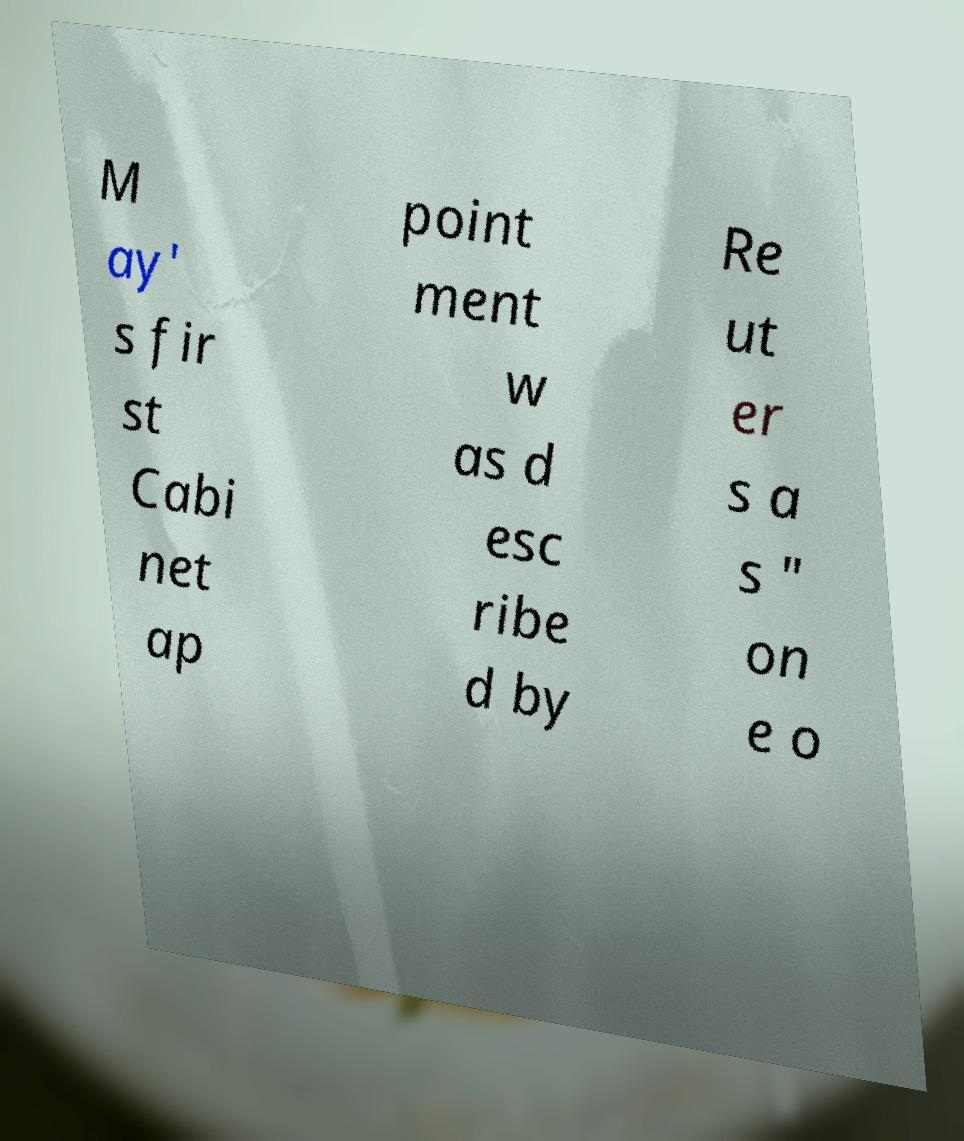Can you read and provide the text displayed in the image?This photo seems to have some interesting text. Can you extract and type it out for me? M ay' s fir st Cabi net ap point ment w as d esc ribe d by Re ut er s a s " on e o 